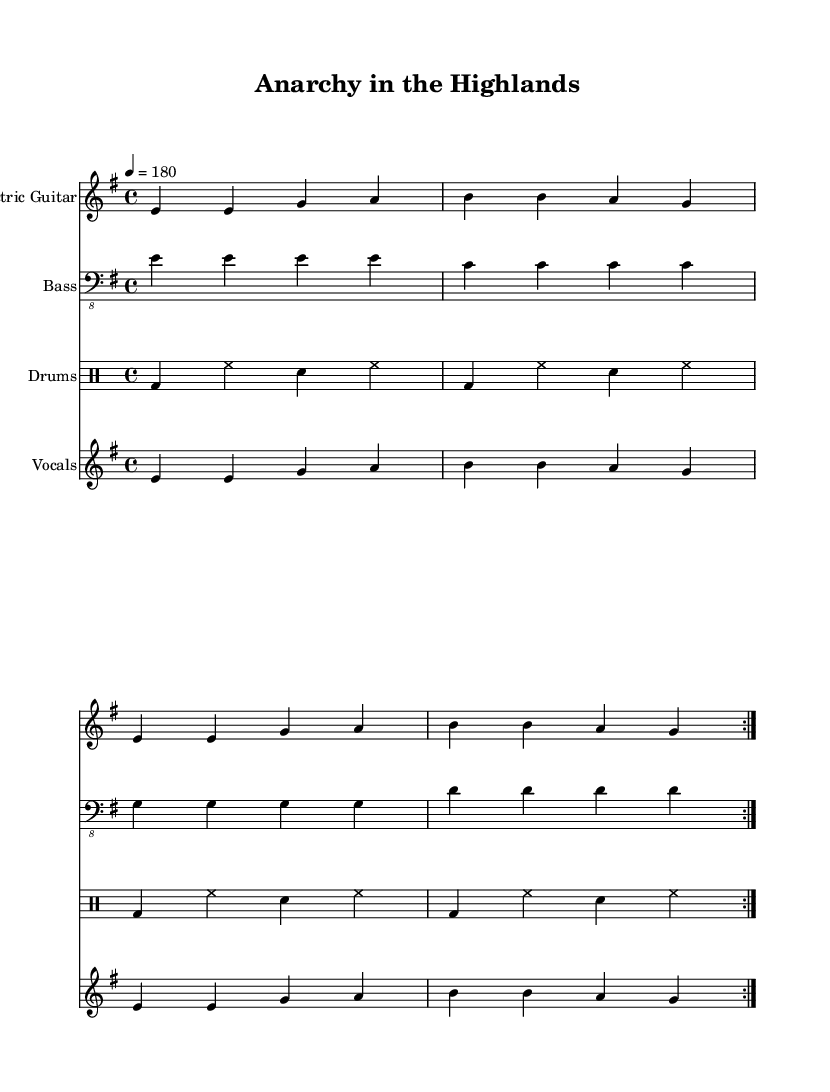What is the key signature of this music? The key signature is E minor, indicated by the presence of one sharp (F sharp) at the beginning of the staff.
Answer: E minor What is the time signature of this piece? The time signature is 4/4, which means there are four beats in each measure and the quarter note gets one beat. This can be found at the beginning of the stave.
Answer: 4/4 What is the tempo marking specified in the score? The tempo marking is indicated by the number "180" which refers to the beats per minute (BPM), showing a fast pace for the piece.
Answer: 180 How many measures are in each repeat section? Each repeat section consists of four measures as indicated by the repetitive patterns in the parts and the volta signs which show a return.
Answer: Four What is the main vocal melody structure? The main vocal melody structure follows a pattern where two phrases are repeated, with each phrase comprising a sequence of four notes. This can be deduced from the repeated notation.
Answer: Repeated phrases What instrument plays the bass part? The bass part is played by the bass guitar, as specified in the instrument name at the beginning of the staff where the bass notes are indicated.
Answer: Bass guitar What type of ensemble is this piece written for? This piece is written for a band ensemble, as it includes electric guitar, bass, drums, and vocals, typical of punk rock anthems challenging social norms.
Answer: Band ensemble 